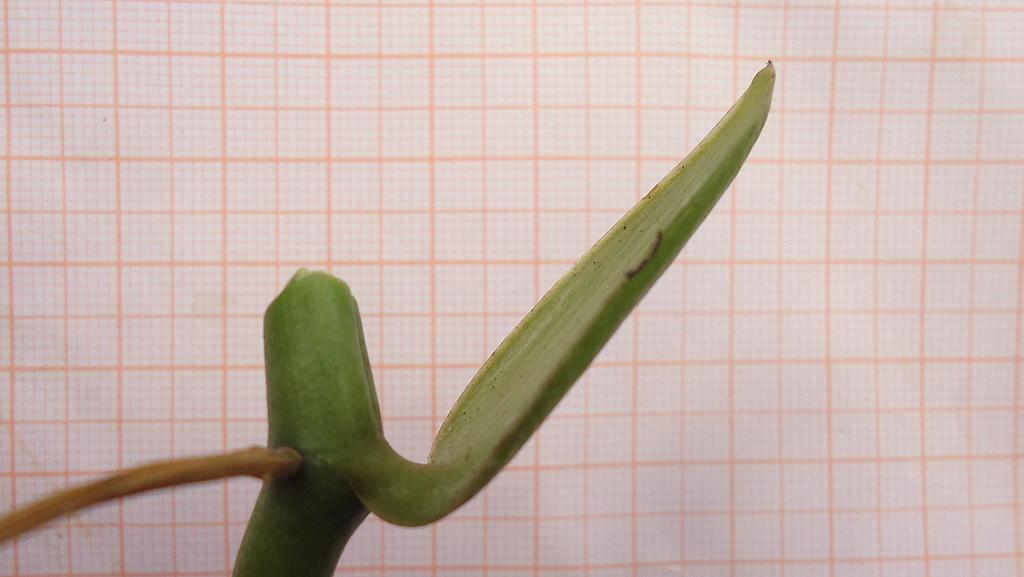What is located in the foreground of the image? There is a plant in the foreground of the image. What can be seen in the background of the image? In the background, there appears to be a paper. What type of bait is being used to catch fish in the image? There is no indication of fishing or bait in the image; it features a plant in the foreground and a paper in the background. 